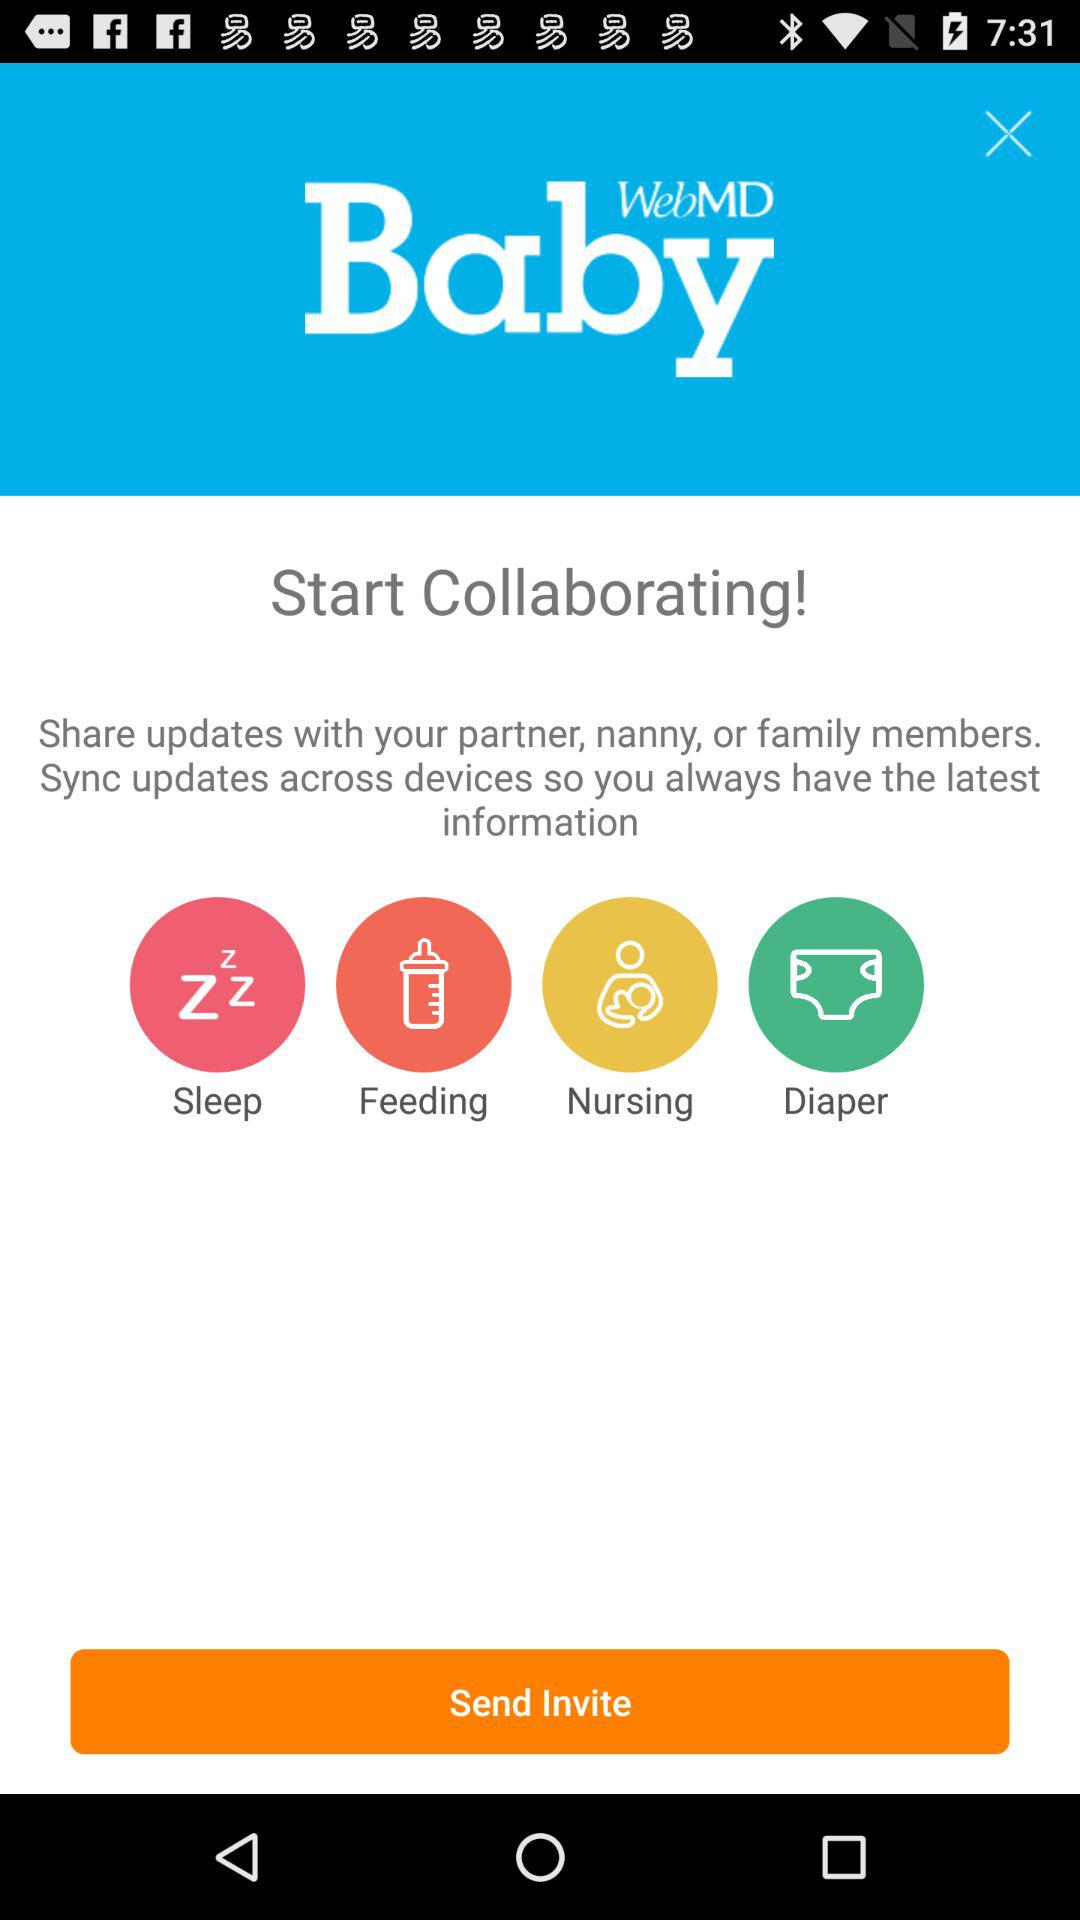With whom can we share the updates? You can share the updates with your partner, nanny, or family members. 